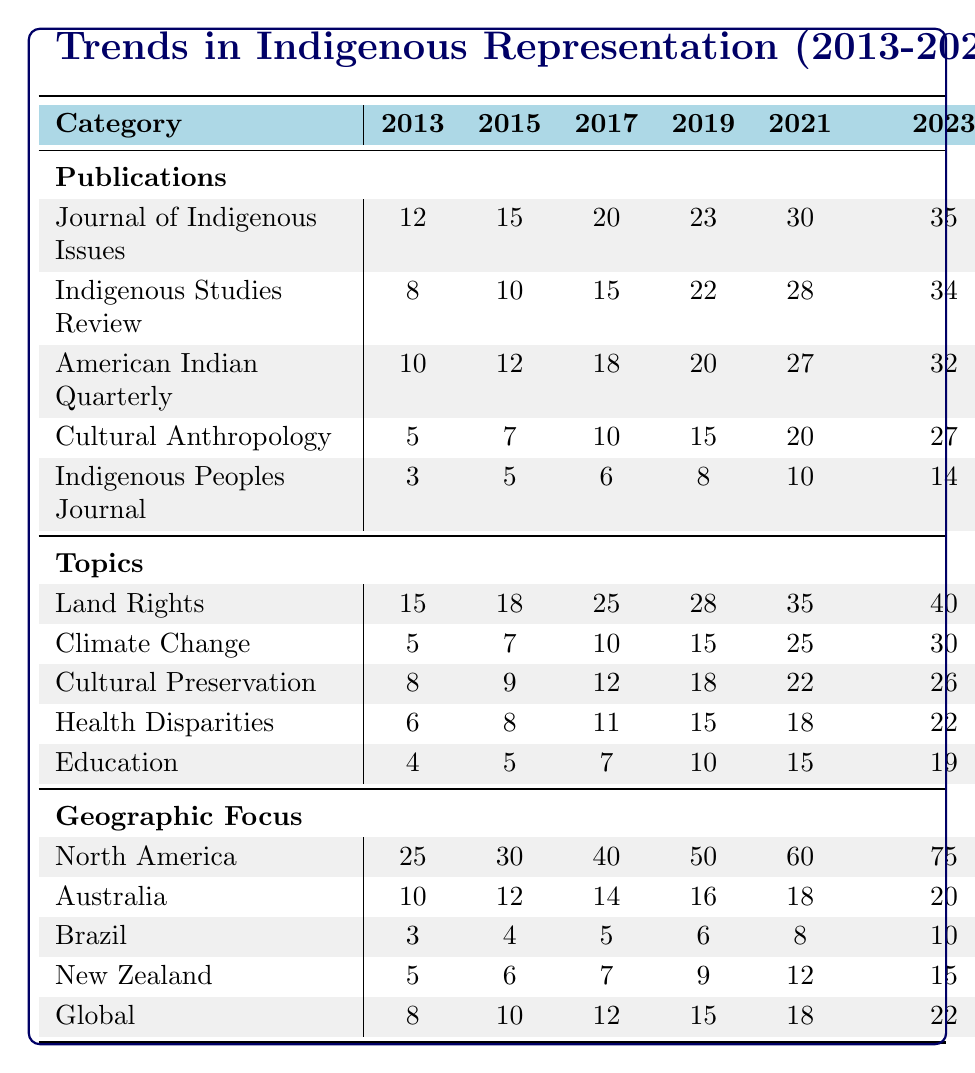What was the total number of publications in the Journal of Indigenous Issues in 2021? Referring to the table, the value for the Journal of Indigenous Issues in 2021 is 30.
Answer: 30 Which topic had the highest number of publications in 2023? In 2023, Land Rights has 40 publications, which is greater than the numbers for Climate Change (30), Cultural Preservation (26), Health Disparities (22), and Education (19).
Answer: Land Rights How many publications were there in total across all journals in 2019? To find the total for 2019, we sum the publications from each journal: 23 (Journal of Indigenous Issues) + 22 (Indigenous Studies Review) + 20 (American Indian Quarterly) + 15 (Cultural Anthropology) + 8 (Indigenous Peoples Journal) = 108.
Answer: 108 Is the number of publications on Climate Change the same in 2015 and 2017? In 2015, the number of publications on Climate Change is 7, while in 2017 it is 10. Therefore, they are not the same.
Answer: No What is the average number of publications on Education from 2013 to 2023? To calculate the average, we first add the publications: 4 + 5 + 7 + 10 + 15 + 19 = 60. Then, we divide the sum by the number of years (6): 60 / 6 = 10.
Answer: 10 Which geographic region experienced the most significant growth in publication numbers from 2013 to 2023? North America started with 25 publications in 2013 and rose to 75 in 2023, a difference of 50. In comparison, Australia grew from 10 to 20 (10), Brazil from 3 to 10 (7), New Zealand from 5 to 15 (10), and Global from 8 to 22 (14). North America experienced the largest growth.
Answer: North America What percentage of total publications in 2021 were dedicated to Land Rights? In 2021, total publications across the five topics are 35 (Land Rights) + 25 (Climate Change) + 22 (Cultural Preservation) + 18 (Health Disparities) + 15 (Education) = 115. Land Rights publications are 35. The percentage calculation is (35 / 115) * 100 ≈ 30.43%.
Answer: Approximately 30.43% Was the publication count in the Indigenous Peoples Journal in 2023 higher than in 2021? The count in the Indigenous Peoples Journal is 14 in 2023 and 10 in 2021, indicating that 2023 is indeed higher than 2021.
Answer: Yes 